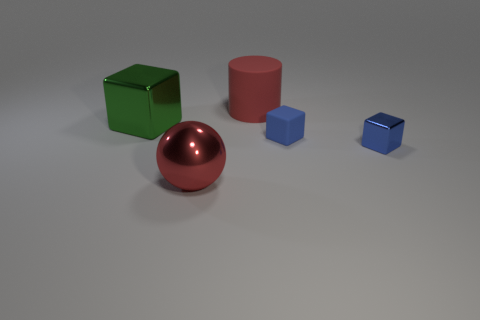Could you guess the purpose of arranging these objects in this way? The arrangement of these objects may be for illustrative purposes, showing a variety of geometric shapes and colors, possibly for a graphical rendering test or an educational display about geometry and shading. 